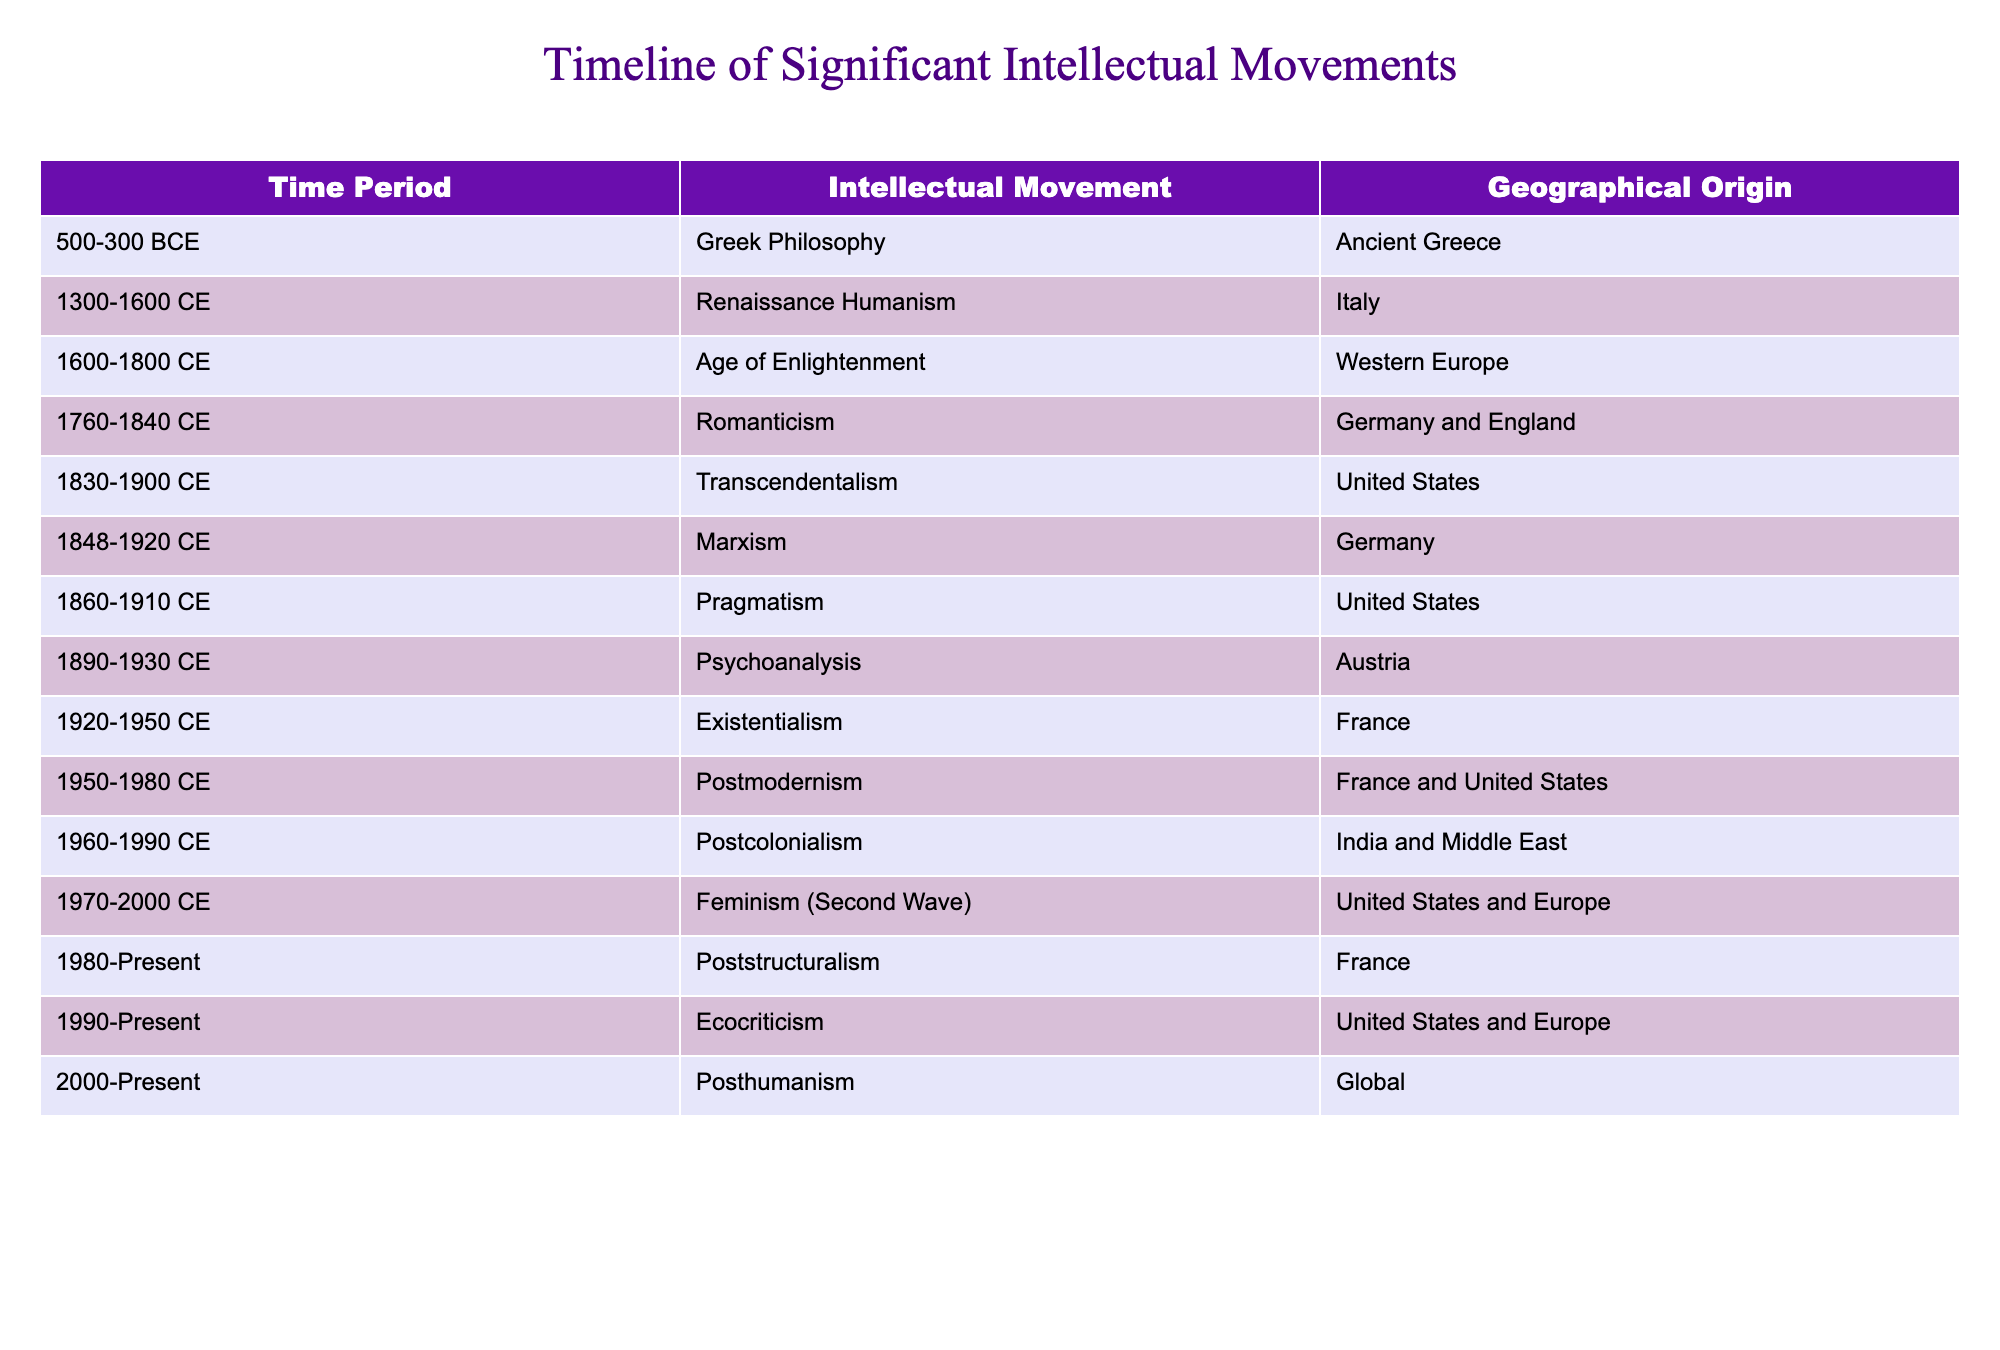What was the geographical origin of the Age of Enlightenment? The table indicates that the Age of Enlightenment had its geographical origin in Western Europe.
Answer: Western Europe Which intellectual movement emerged in the United States during 1830-1900 CE? The table shows that Transcendentalism is the intellectual movement that emerged in the United States during this time period.
Answer: Transcendentalism Did the Renaissance Humanism movement originate in France? The table clearly states that Renaissance Humanism originated in Italy, so the answer is no.
Answer: No What is the time period for Postmodernism as an intellectual movement? By examining the table, we can see that the time period for Postmodernism is from 1950 to 1980 CE.
Answer: 1950-1980 CE Which two intellectual movements had their origins in the United States? By referring to the table, we see that the movements are Transcendentalism (1830-1900 CE) and Pragmatism (1860-1910 CE).
Answer: Transcendentalism and Pragmatism What was the earliest intellectual movement listed in the table? The table indicates that Greek Philosophy, spanning from 500-300 BCE, is the earliest intellectual movement listed.
Answer: Greek Philosophy How many intellectual movements originated in France? Referring to the table, we see Existentialism (1920-1950 CE) and Postmodernism (1950-1980 CE) originated in France, giving us a total of two.
Answer: 2 Which intellectual movement followed Marxism in the timeline? By examining the time periods, we find that Pragmatism (1860-1910 CE) succeeded Marxism (1848-1920 CE) in the timeline.
Answer: Pragmatism What is the last intellectual movement listed on the timeline? The table indicates that Posthumanism, which started in 2000 and continues to the present, is the last movement listed.
Answer: Posthumanism Is Feminism (Second Wave) the only movement that originated in both the United States and Europe? According to the table, Feminism (Second Wave) is not the only one; Postmodernism also originated in both the United States and France. Therefore, the statement is false.
Answer: No 